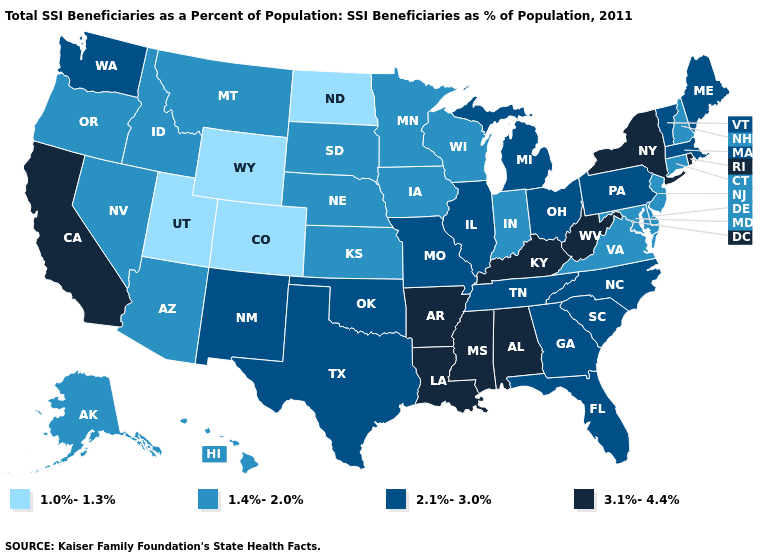What is the value of New Mexico?
Be succinct. 2.1%-3.0%. What is the lowest value in the USA?
Write a very short answer. 1.0%-1.3%. Among the states that border Vermont , does New York have the highest value?
Concise answer only. Yes. Does New Mexico have the same value as Vermont?
Quick response, please. Yes. Name the states that have a value in the range 2.1%-3.0%?
Be succinct. Florida, Georgia, Illinois, Maine, Massachusetts, Michigan, Missouri, New Mexico, North Carolina, Ohio, Oklahoma, Pennsylvania, South Carolina, Tennessee, Texas, Vermont, Washington. Among the states that border Nebraska , does Colorado have the lowest value?
Short answer required. Yes. Does Iowa have the same value as Wyoming?
Quick response, please. No. Name the states that have a value in the range 2.1%-3.0%?
Answer briefly. Florida, Georgia, Illinois, Maine, Massachusetts, Michigan, Missouri, New Mexico, North Carolina, Ohio, Oklahoma, Pennsylvania, South Carolina, Tennessee, Texas, Vermont, Washington. Which states have the lowest value in the South?
Quick response, please. Delaware, Maryland, Virginia. What is the value of Ohio?
Concise answer only. 2.1%-3.0%. Does Kentucky have the highest value in the USA?
Keep it brief. Yes. What is the value of Illinois?
Be succinct. 2.1%-3.0%. Which states have the lowest value in the USA?
Write a very short answer. Colorado, North Dakota, Utah, Wyoming. Name the states that have a value in the range 2.1%-3.0%?
Write a very short answer. Florida, Georgia, Illinois, Maine, Massachusetts, Michigan, Missouri, New Mexico, North Carolina, Ohio, Oklahoma, Pennsylvania, South Carolina, Tennessee, Texas, Vermont, Washington. Does the first symbol in the legend represent the smallest category?
Be succinct. Yes. 